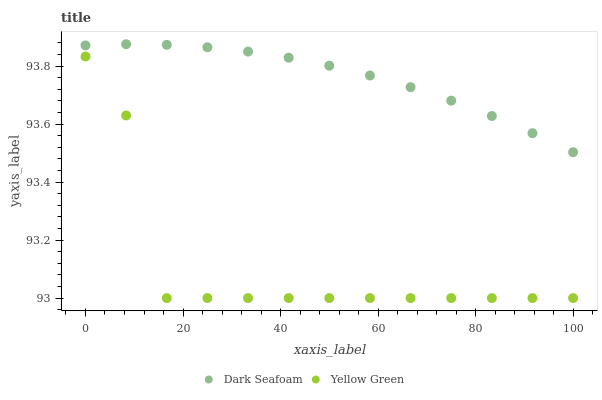Does Yellow Green have the minimum area under the curve?
Answer yes or no. Yes. Does Dark Seafoam have the maximum area under the curve?
Answer yes or no. Yes. Does Yellow Green have the maximum area under the curve?
Answer yes or no. No. Is Dark Seafoam the smoothest?
Answer yes or no. Yes. Is Yellow Green the roughest?
Answer yes or no. Yes. Is Yellow Green the smoothest?
Answer yes or no. No. Does Yellow Green have the lowest value?
Answer yes or no. Yes. Does Dark Seafoam have the highest value?
Answer yes or no. Yes. Does Yellow Green have the highest value?
Answer yes or no. No. Is Yellow Green less than Dark Seafoam?
Answer yes or no. Yes. Is Dark Seafoam greater than Yellow Green?
Answer yes or no. Yes. Does Yellow Green intersect Dark Seafoam?
Answer yes or no. No. 